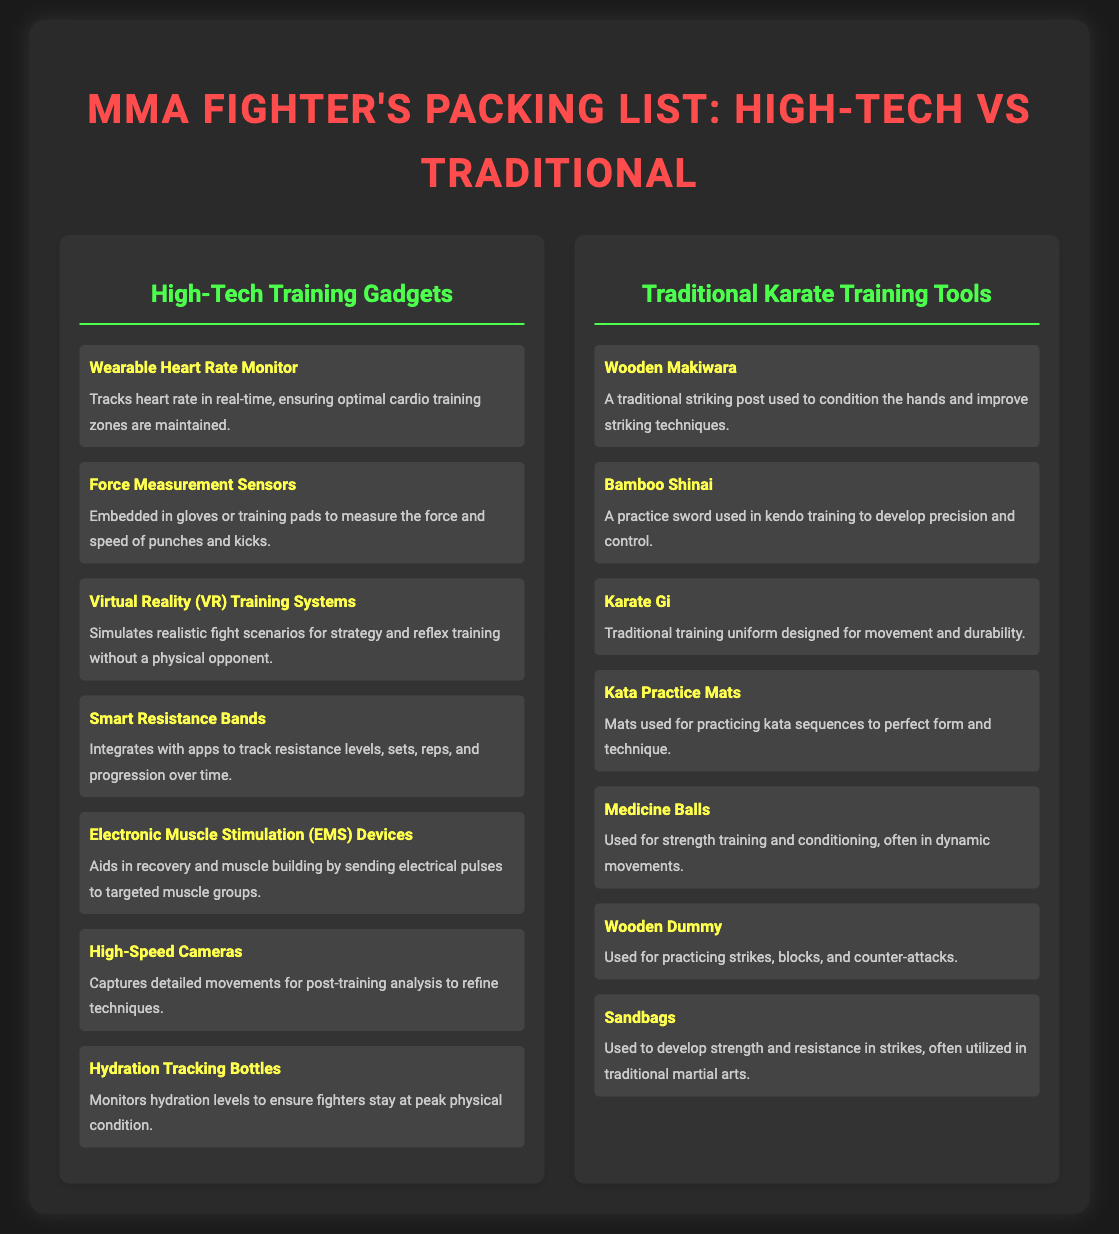what is one type of high-tech training gadget mentioned in the list? The list includes several high-tech training gadgets, one of which is a Wearable Heart Rate Monitor.
Answer: Wearable Heart Rate Monitor how many traditional karate training tools are listed? The document includes a total of seven traditional karate training tools as per the list provided.
Answer: 7 what is the item used for practicing kata sequences? The document specifies that Kata Practice Mats are used for practicing kata sequences.
Answer: Kata Practice Mats which item is used to measure force in punches and kicks? The Force Measurement Sensors are indicated as the items used for measuring force in strikes.
Answer: Force Measurement Sensors what is the purpose of Electronic Muscle Stimulation devices? These devices are primarily used to aid in recovery and muscle building through electrical pulses.
Answer: Recovery and muscle building which gadget helps monitor hydration levels? The hydration tracking bottles are used to monitor the hydration levels of fighters.
Answer: Hydration Tracking Bottles name a traditional karate training tool used for conditioning the hands. The Wooden Makiwara is the traditional tool used for conditioning the hands.
Answer: Wooden Makiwara what type of technology does a Virtual Reality training system simulate? The Virtual Reality training system simulates realistic fight scenarios.
Answer: Fight scenarios how does Smart Resistance Bands assist fighters? Smart Resistance Bands assist by integrating with apps to track training metrics.
Answer: Track resistance levels, sets, reps, and progression 